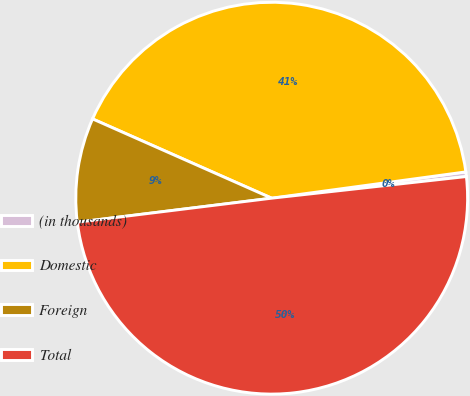Convert chart. <chart><loc_0><loc_0><loc_500><loc_500><pie_chart><fcel>(in thousands)<fcel>Domestic<fcel>Foreign<fcel>Total<nl><fcel>0.38%<fcel>41.23%<fcel>8.59%<fcel>49.81%<nl></chart> 